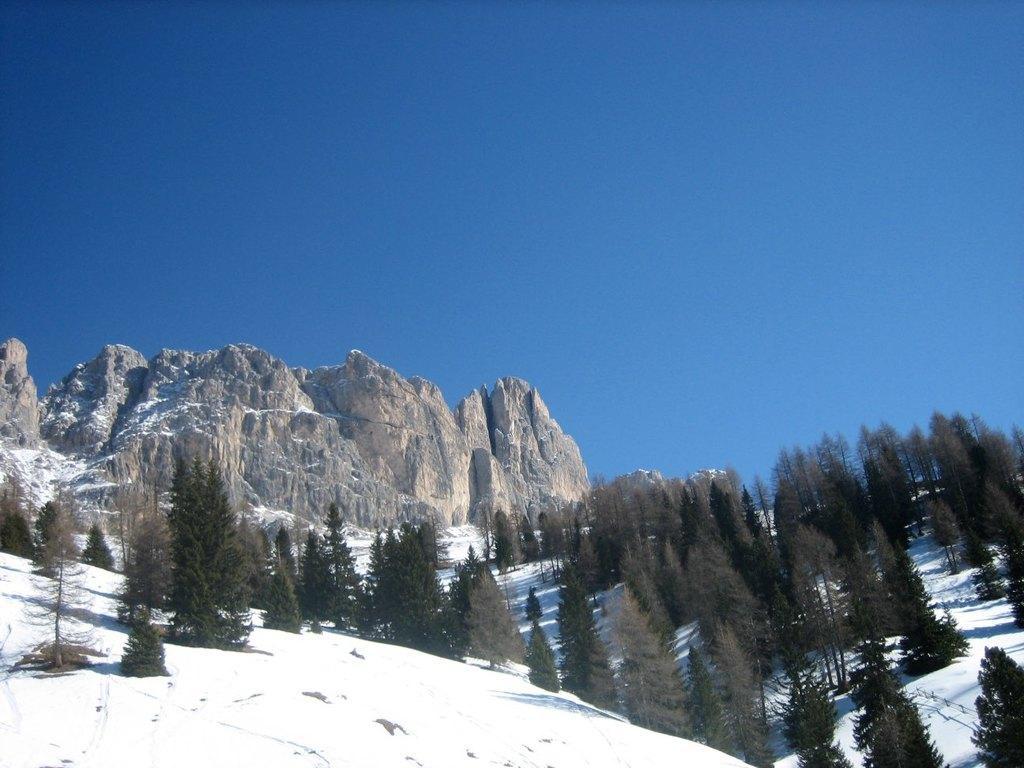Describe this image in one or two sentences. In this image, in the middle there are trees, hills, stones, ice, sky. 